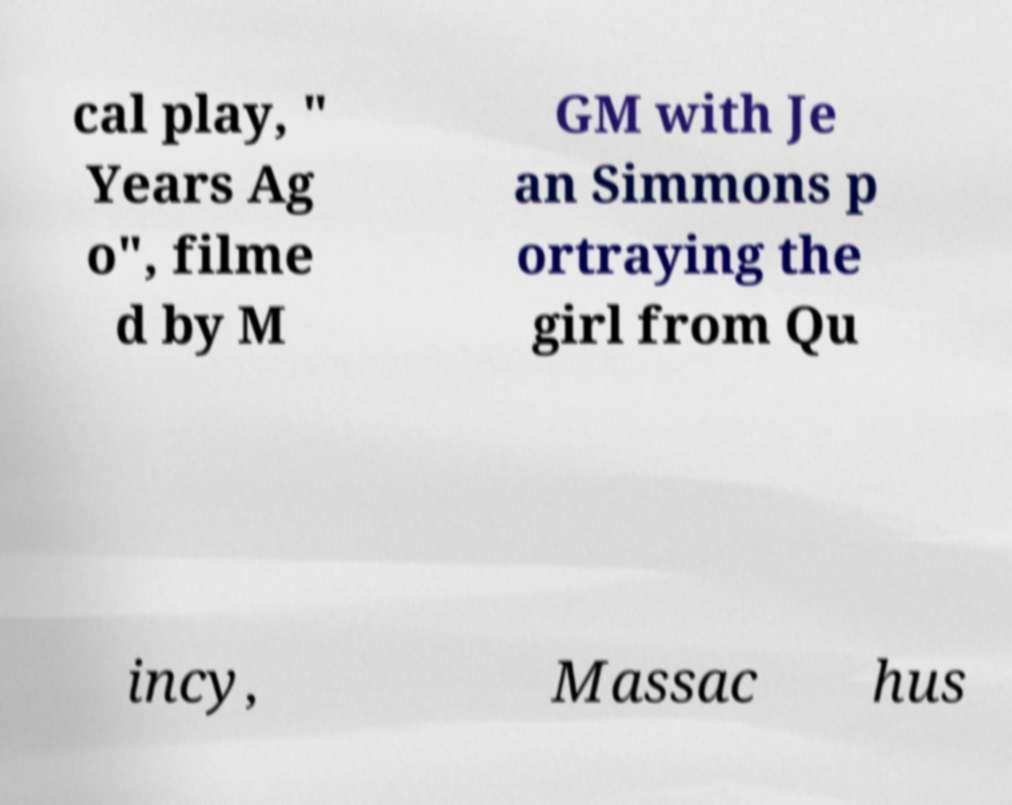Could you assist in decoding the text presented in this image and type it out clearly? cal play, " Years Ag o", filme d by M GM with Je an Simmons p ortraying the girl from Qu incy, Massac hus 